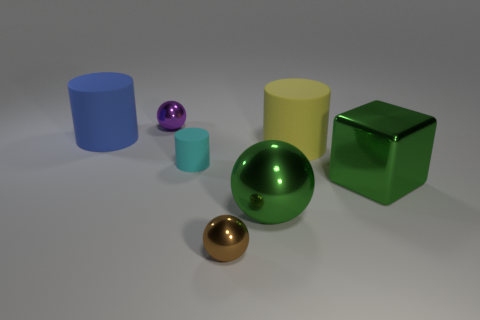Subtract 1 spheres. How many spheres are left? 2 Subtract all purple shiny balls. How many balls are left? 2 Add 1 big objects. How many objects exist? 8 Subtract all spheres. How many objects are left? 4 Add 4 tiny brown things. How many tiny brown things are left? 5 Add 6 large cyan cylinders. How many large cyan cylinders exist? 6 Subtract 1 brown spheres. How many objects are left? 6 Subtract all small yellow metallic cubes. Subtract all tiny metallic spheres. How many objects are left? 5 